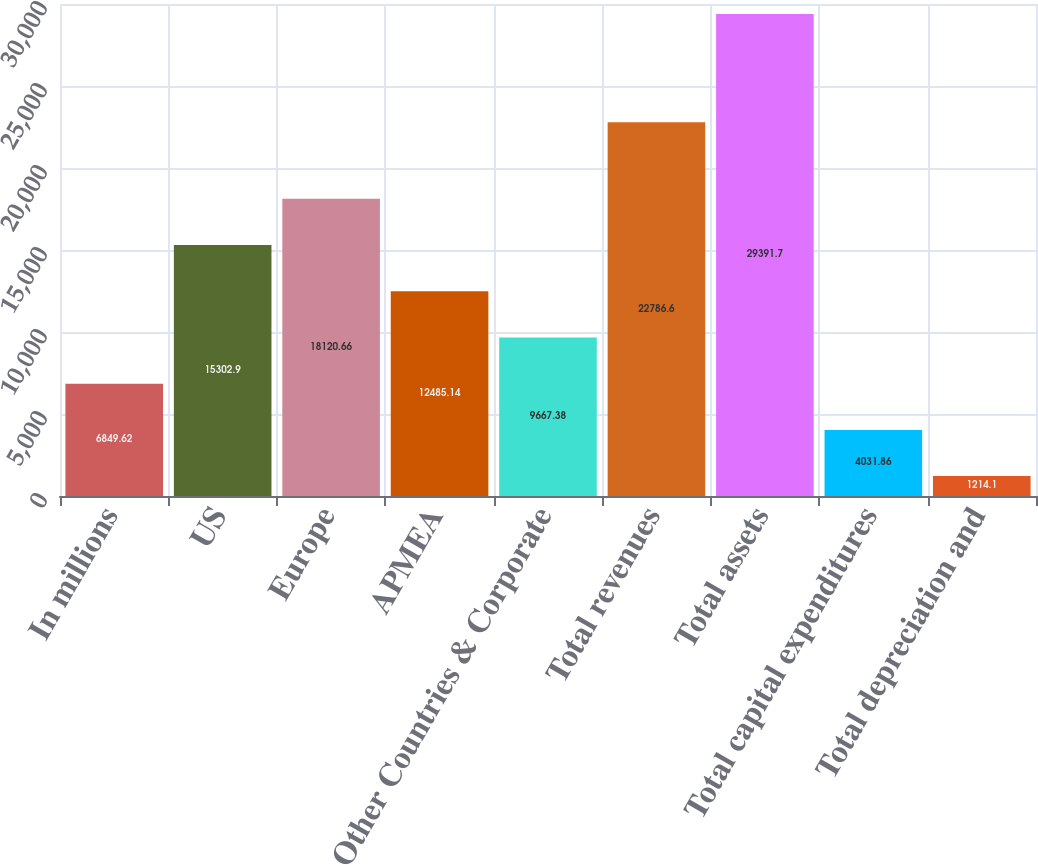Convert chart. <chart><loc_0><loc_0><loc_500><loc_500><bar_chart><fcel>In millions<fcel>US<fcel>Europe<fcel>APMEA<fcel>Other Countries & Corporate<fcel>Total revenues<fcel>Total assets<fcel>Total capital expenditures<fcel>Total depreciation and<nl><fcel>6849.62<fcel>15302.9<fcel>18120.7<fcel>12485.1<fcel>9667.38<fcel>22786.6<fcel>29391.7<fcel>4031.86<fcel>1214.1<nl></chart> 